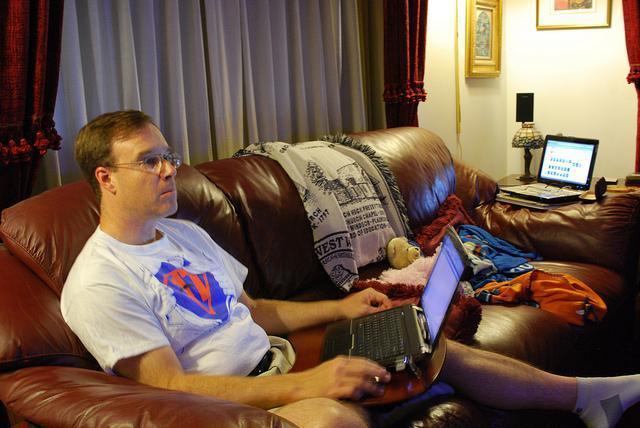Verify the accuracy of this image caption: "The person is touching the teddy bear.".
Answer yes or no. No. Does the image validate the caption "The person is touching the couch."?
Answer yes or no. Yes. 